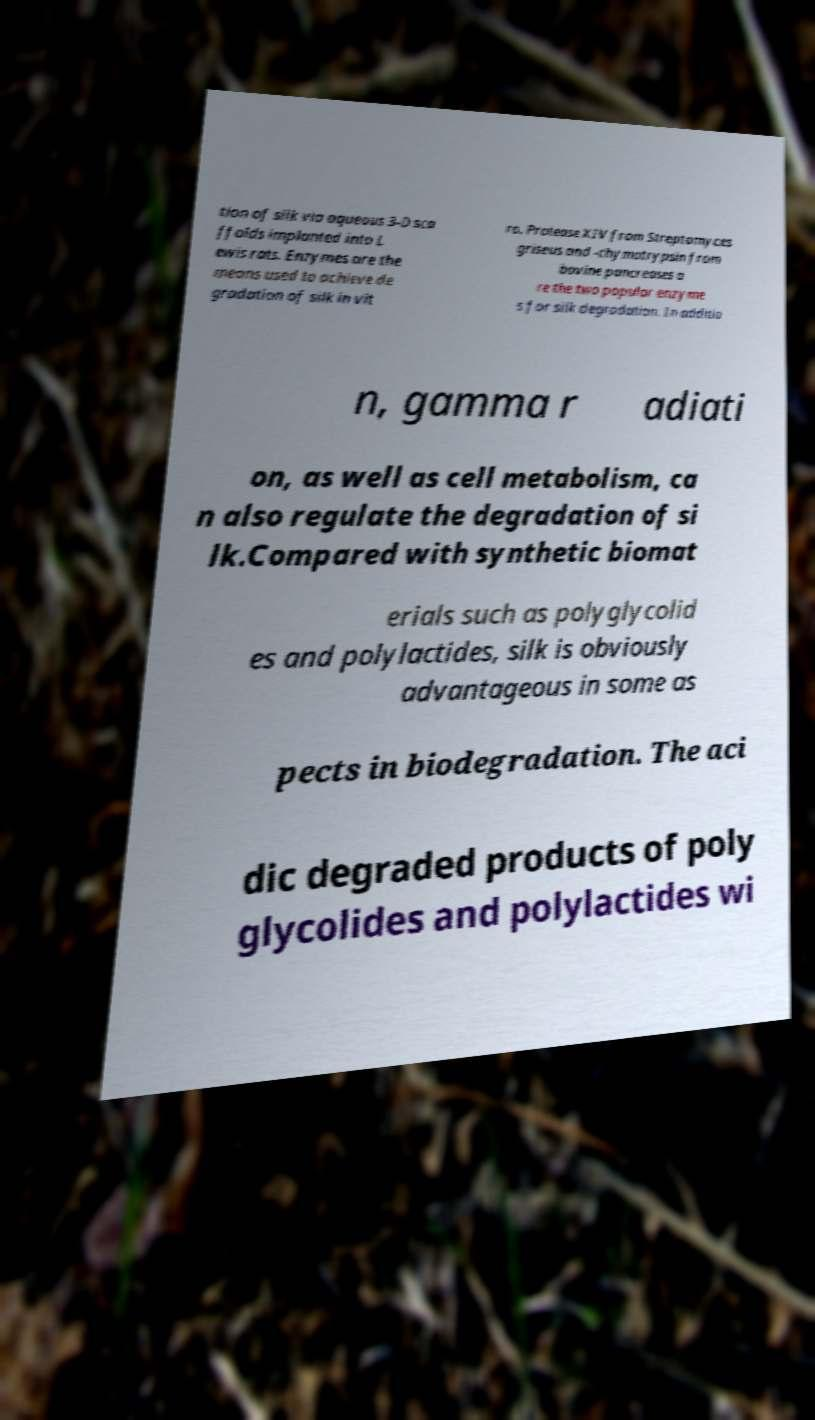Can you accurately transcribe the text from the provided image for me? tion of silk via aqueous 3-D sca ffolds implanted into L ewis rats. Enzymes are the means used to achieve de gradation of silk in vit ro. Protease XIV from Streptomyces griseus and -chymotrypsin from bovine pancreases a re the two popular enzyme s for silk degradation. In additio n, gamma r adiati on, as well as cell metabolism, ca n also regulate the degradation of si lk.Compared with synthetic biomat erials such as polyglycolid es and polylactides, silk is obviously advantageous in some as pects in biodegradation. The aci dic degraded products of poly glycolides and polylactides wi 